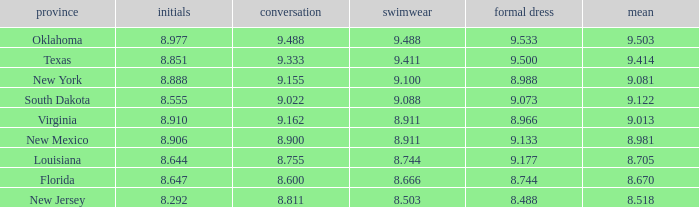 what's the preliminaries where state is south dakota 8.555. 